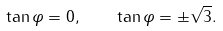<formula> <loc_0><loc_0><loc_500><loc_500>\tan \varphi = 0 , \quad \tan \varphi = \pm \sqrt { 3 } .</formula> 